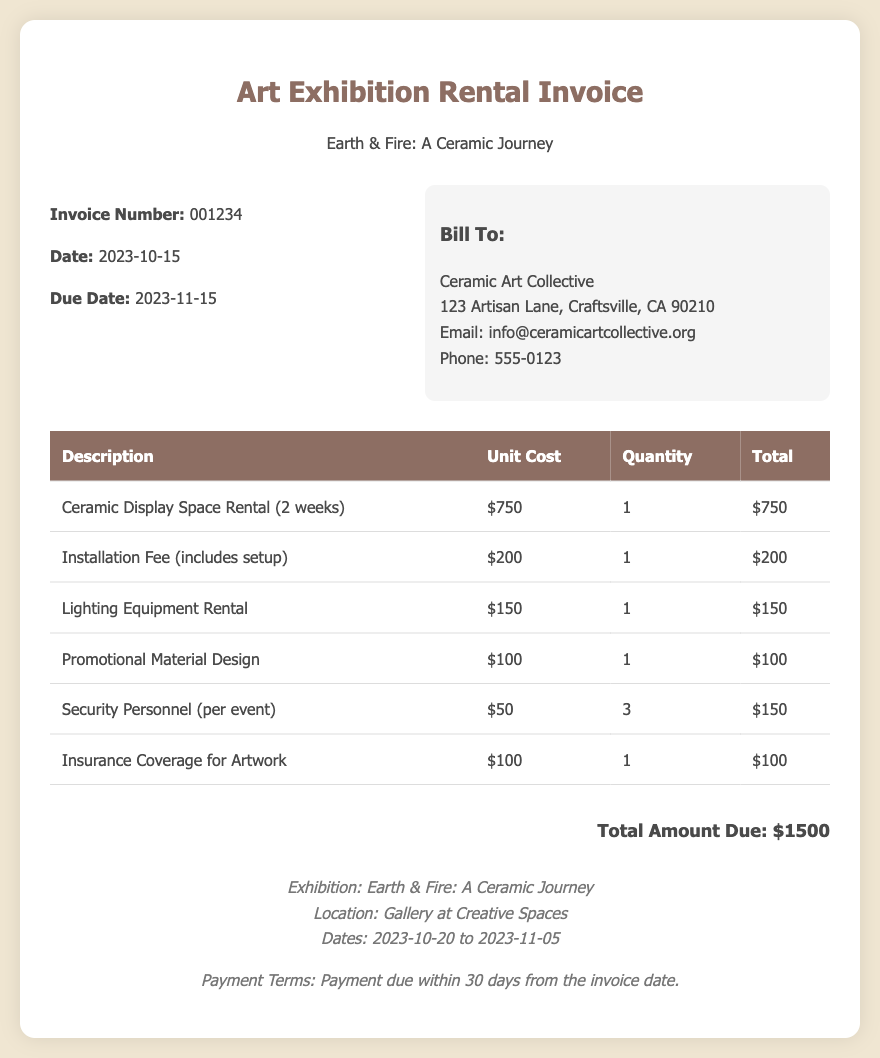What is the invoice number? The invoice number is listed near the top of the document under invoice details.
Answer: 001234 What is the total amount due? The total amount due is provided in the total section of the document.
Answer: $1500 What is the date of the invoice? The date of the invoice is mentioned alongside the invoice number in the document details.
Answer: 2023-10-15 What service is charged for $200? The document lists the installation fee as $200, which includes setup.
Answer: Installation Fee How many security personnel charges are included? The number of security personnel is specified in the invoice details as 3.
Answer: 3 What is the rental duration for the ceramic display space? The rental duration is stated in the item description for the ceramic display space rental.
Answer: 2 weeks What location is the exhibition held at? The location of the exhibition is mentioned in the footer section of the document.
Answer: Gallery at Creative Spaces On what date does the exhibition start? The start date for the exhibition is provided in the footer section.
Answer: 2023-10-20 What type of coverage is included for the artwork? The insurance coverage for the artwork is specified in the itemized costs.
Answer: Insurance Coverage 